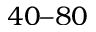Convert formula to latex. <formula><loc_0><loc_0><loc_500><loc_500>4 0 8 0</formula> 